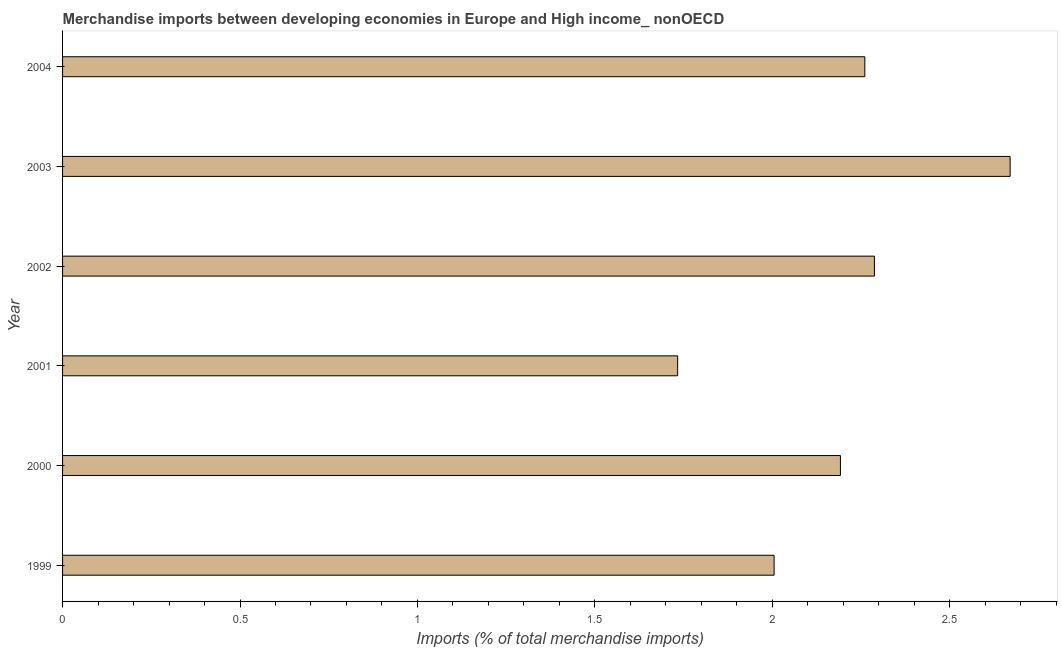What is the title of the graph?
Give a very brief answer. Merchandise imports between developing economies in Europe and High income_ nonOECD. What is the label or title of the X-axis?
Offer a very short reply. Imports (% of total merchandise imports). What is the label or title of the Y-axis?
Offer a terse response. Year. What is the merchandise imports in 2002?
Your response must be concise. 2.29. Across all years, what is the maximum merchandise imports?
Give a very brief answer. 2.67. Across all years, what is the minimum merchandise imports?
Your answer should be very brief. 1.73. What is the sum of the merchandise imports?
Offer a terse response. 13.15. What is the difference between the merchandise imports in 2000 and 2004?
Your response must be concise. -0.07. What is the average merchandise imports per year?
Offer a very short reply. 2.19. What is the median merchandise imports?
Provide a succinct answer. 2.23. What is the ratio of the merchandise imports in 2002 to that in 2004?
Make the answer very short. 1.01. Is the difference between the merchandise imports in 2000 and 2003 greater than the difference between any two years?
Keep it short and to the point. No. What is the difference between the highest and the second highest merchandise imports?
Your answer should be very brief. 0.38. What is the difference between the highest and the lowest merchandise imports?
Offer a very short reply. 0.94. How many years are there in the graph?
Your answer should be very brief. 6. What is the Imports (% of total merchandise imports) in 1999?
Make the answer very short. 2.01. What is the Imports (% of total merchandise imports) of 2000?
Make the answer very short. 2.19. What is the Imports (% of total merchandise imports) of 2001?
Give a very brief answer. 1.73. What is the Imports (% of total merchandise imports) of 2002?
Offer a terse response. 2.29. What is the Imports (% of total merchandise imports) in 2003?
Your response must be concise. 2.67. What is the Imports (% of total merchandise imports) in 2004?
Provide a succinct answer. 2.26. What is the difference between the Imports (% of total merchandise imports) in 1999 and 2000?
Ensure brevity in your answer.  -0.19. What is the difference between the Imports (% of total merchandise imports) in 1999 and 2001?
Ensure brevity in your answer.  0.27. What is the difference between the Imports (% of total merchandise imports) in 1999 and 2002?
Provide a short and direct response. -0.28. What is the difference between the Imports (% of total merchandise imports) in 1999 and 2003?
Your answer should be compact. -0.67. What is the difference between the Imports (% of total merchandise imports) in 1999 and 2004?
Provide a succinct answer. -0.26. What is the difference between the Imports (% of total merchandise imports) in 2000 and 2001?
Your response must be concise. 0.46. What is the difference between the Imports (% of total merchandise imports) in 2000 and 2002?
Ensure brevity in your answer.  -0.1. What is the difference between the Imports (% of total merchandise imports) in 2000 and 2003?
Your answer should be very brief. -0.48. What is the difference between the Imports (% of total merchandise imports) in 2000 and 2004?
Provide a short and direct response. -0.07. What is the difference between the Imports (% of total merchandise imports) in 2001 and 2002?
Provide a succinct answer. -0.55. What is the difference between the Imports (% of total merchandise imports) in 2001 and 2003?
Offer a terse response. -0.94. What is the difference between the Imports (% of total merchandise imports) in 2001 and 2004?
Your answer should be compact. -0.53. What is the difference between the Imports (% of total merchandise imports) in 2002 and 2003?
Make the answer very short. -0.38. What is the difference between the Imports (% of total merchandise imports) in 2002 and 2004?
Provide a short and direct response. 0.03. What is the difference between the Imports (% of total merchandise imports) in 2003 and 2004?
Provide a short and direct response. 0.41. What is the ratio of the Imports (% of total merchandise imports) in 1999 to that in 2000?
Offer a terse response. 0.92. What is the ratio of the Imports (% of total merchandise imports) in 1999 to that in 2001?
Ensure brevity in your answer.  1.16. What is the ratio of the Imports (% of total merchandise imports) in 1999 to that in 2002?
Make the answer very short. 0.88. What is the ratio of the Imports (% of total merchandise imports) in 1999 to that in 2003?
Your answer should be very brief. 0.75. What is the ratio of the Imports (% of total merchandise imports) in 1999 to that in 2004?
Give a very brief answer. 0.89. What is the ratio of the Imports (% of total merchandise imports) in 2000 to that in 2001?
Give a very brief answer. 1.26. What is the ratio of the Imports (% of total merchandise imports) in 2000 to that in 2002?
Offer a terse response. 0.96. What is the ratio of the Imports (% of total merchandise imports) in 2000 to that in 2003?
Ensure brevity in your answer.  0.82. What is the ratio of the Imports (% of total merchandise imports) in 2001 to that in 2002?
Your response must be concise. 0.76. What is the ratio of the Imports (% of total merchandise imports) in 2001 to that in 2003?
Keep it short and to the point. 0.65. What is the ratio of the Imports (% of total merchandise imports) in 2001 to that in 2004?
Offer a very short reply. 0.77. What is the ratio of the Imports (% of total merchandise imports) in 2002 to that in 2003?
Ensure brevity in your answer.  0.86. What is the ratio of the Imports (% of total merchandise imports) in 2002 to that in 2004?
Offer a terse response. 1.01. What is the ratio of the Imports (% of total merchandise imports) in 2003 to that in 2004?
Make the answer very short. 1.18. 